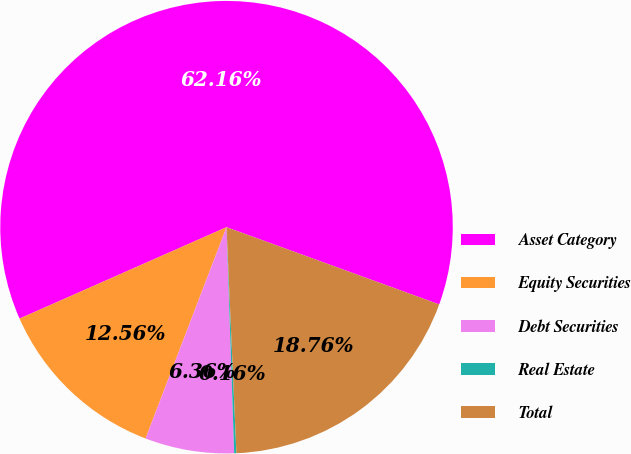Convert chart to OTSL. <chart><loc_0><loc_0><loc_500><loc_500><pie_chart><fcel>Asset Category<fcel>Equity Securities<fcel>Debt Securities<fcel>Real Estate<fcel>Total<nl><fcel>62.17%<fcel>12.56%<fcel>6.36%<fcel>0.16%<fcel>18.76%<nl></chart> 